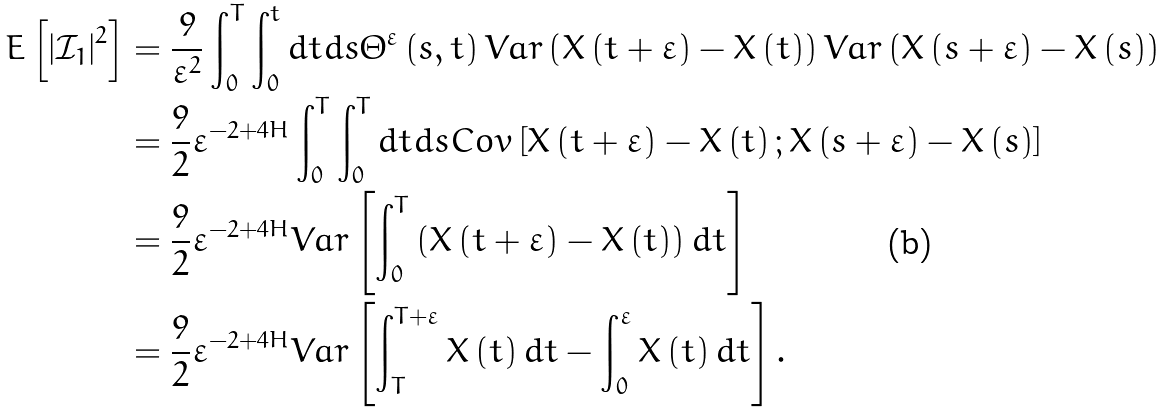Convert formula to latex. <formula><loc_0><loc_0><loc_500><loc_500>E \left [ \left | \mathcal { I } _ { 1 } \right | ^ { 2 } \right ] & = \frac { 9 } { \varepsilon ^ { 2 } } \int _ { 0 } ^ { T } \int _ { 0 } ^ { t } d t d s \Theta ^ { \varepsilon } \left ( s , t \right ) V a r \left ( X \left ( t + \varepsilon \right ) - X \left ( t \right ) \right ) V a r \left ( X \left ( s + \varepsilon \right ) - X \left ( s \right ) \right ) \\ & = \frac { 9 } { 2 } \varepsilon ^ { - 2 + 4 H } \int _ { 0 } ^ { T } \int _ { 0 } ^ { T } d t d s C o v \left [ X \left ( t + \varepsilon \right ) - X \left ( t \right ) ; X \left ( s + \varepsilon \right ) - X \left ( s \right ) \right ] \\ & = \frac { 9 } { 2 } \varepsilon ^ { - 2 + 4 H } V a r \left [ \int _ { 0 } ^ { T } \left ( X \left ( t + \varepsilon \right ) - X \left ( t \right ) \right ) d t \right ] \\ & = \frac { 9 } { 2 } \varepsilon ^ { - 2 + 4 H } V a r \left [ \int _ { T } ^ { T + \varepsilon } X \left ( t \right ) d t - \int _ { 0 } ^ { \varepsilon } X \left ( t \right ) d t \right ] .</formula> 